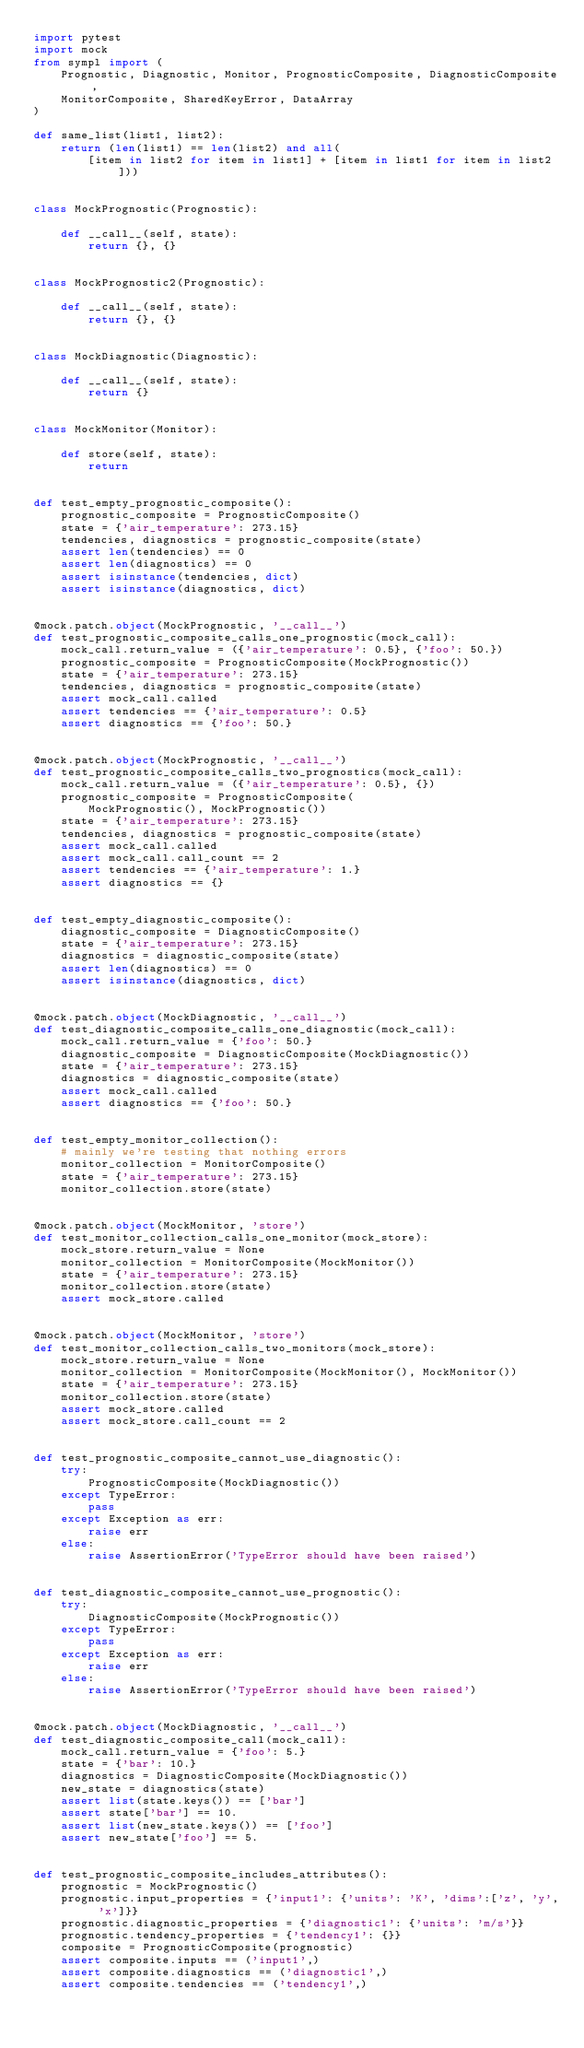<code> <loc_0><loc_0><loc_500><loc_500><_Python_>import pytest
import mock
from sympl import (
    Prognostic, Diagnostic, Monitor, PrognosticComposite, DiagnosticComposite,
    MonitorComposite, SharedKeyError, DataArray
)

def same_list(list1, list2):
    return (len(list1) == len(list2) and all(
        [item in list2 for item in list1] + [item in list1 for item in list2]))


class MockPrognostic(Prognostic):

    def __call__(self, state):
        return {}, {}


class MockPrognostic2(Prognostic):

    def __call__(self, state):
        return {}, {}


class MockDiagnostic(Diagnostic):

    def __call__(self, state):
        return {}


class MockMonitor(Monitor):

    def store(self, state):
        return


def test_empty_prognostic_composite():
    prognostic_composite = PrognosticComposite()
    state = {'air_temperature': 273.15}
    tendencies, diagnostics = prognostic_composite(state)
    assert len(tendencies) == 0
    assert len(diagnostics) == 0
    assert isinstance(tendencies, dict)
    assert isinstance(diagnostics, dict)


@mock.patch.object(MockPrognostic, '__call__')
def test_prognostic_composite_calls_one_prognostic(mock_call):
    mock_call.return_value = ({'air_temperature': 0.5}, {'foo': 50.})
    prognostic_composite = PrognosticComposite(MockPrognostic())
    state = {'air_temperature': 273.15}
    tendencies, diagnostics = prognostic_composite(state)
    assert mock_call.called
    assert tendencies == {'air_temperature': 0.5}
    assert diagnostics == {'foo': 50.}


@mock.patch.object(MockPrognostic, '__call__')
def test_prognostic_composite_calls_two_prognostics(mock_call):
    mock_call.return_value = ({'air_temperature': 0.5}, {})
    prognostic_composite = PrognosticComposite(
        MockPrognostic(), MockPrognostic())
    state = {'air_temperature': 273.15}
    tendencies, diagnostics = prognostic_composite(state)
    assert mock_call.called
    assert mock_call.call_count == 2
    assert tendencies == {'air_temperature': 1.}
    assert diagnostics == {}


def test_empty_diagnostic_composite():
    diagnostic_composite = DiagnosticComposite()
    state = {'air_temperature': 273.15}
    diagnostics = diagnostic_composite(state)
    assert len(diagnostics) == 0
    assert isinstance(diagnostics, dict)


@mock.patch.object(MockDiagnostic, '__call__')
def test_diagnostic_composite_calls_one_diagnostic(mock_call):
    mock_call.return_value = {'foo': 50.}
    diagnostic_composite = DiagnosticComposite(MockDiagnostic())
    state = {'air_temperature': 273.15}
    diagnostics = diagnostic_composite(state)
    assert mock_call.called
    assert diagnostics == {'foo': 50.}


def test_empty_monitor_collection():
    # mainly we're testing that nothing errors
    monitor_collection = MonitorComposite()
    state = {'air_temperature': 273.15}
    monitor_collection.store(state)


@mock.patch.object(MockMonitor, 'store')
def test_monitor_collection_calls_one_monitor(mock_store):
    mock_store.return_value = None
    monitor_collection = MonitorComposite(MockMonitor())
    state = {'air_temperature': 273.15}
    monitor_collection.store(state)
    assert mock_store.called


@mock.patch.object(MockMonitor, 'store')
def test_monitor_collection_calls_two_monitors(mock_store):
    mock_store.return_value = None
    monitor_collection = MonitorComposite(MockMonitor(), MockMonitor())
    state = {'air_temperature': 273.15}
    monitor_collection.store(state)
    assert mock_store.called
    assert mock_store.call_count == 2


def test_prognostic_composite_cannot_use_diagnostic():
    try:
        PrognosticComposite(MockDiagnostic())
    except TypeError:
        pass
    except Exception as err:
        raise err
    else:
        raise AssertionError('TypeError should have been raised')


def test_diagnostic_composite_cannot_use_prognostic():
    try:
        DiagnosticComposite(MockPrognostic())
    except TypeError:
        pass
    except Exception as err:
        raise err
    else:
        raise AssertionError('TypeError should have been raised')


@mock.patch.object(MockDiagnostic, '__call__')
def test_diagnostic_composite_call(mock_call):
    mock_call.return_value = {'foo': 5.}
    state = {'bar': 10.}
    diagnostics = DiagnosticComposite(MockDiagnostic())
    new_state = diagnostics(state)
    assert list(state.keys()) == ['bar']
    assert state['bar'] == 10.
    assert list(new_state.keys()) == ['foo']
    assert new_state['foo'] == 5.


def test_prognostic_composite_includes_attributes():
    prognostic = MockPrognostic()
    prognostic.input_properties = {'input1': {'units': 'K', 'dims':['z', 'y', 'x']}}
    prognostic.diagnostic_properties = {'diagnostic1': {'units': 'm/s'}}
    prognostic.tendency_properties = {'tendency1': {}}
    composite = PrognosticComposite(prognostic)
    assert composite.inputs == ('input1',)
    assert composite.diagnostics == ('diagnostic1',)
    assert composite.tendencies == ('tendency1',)

</code> 